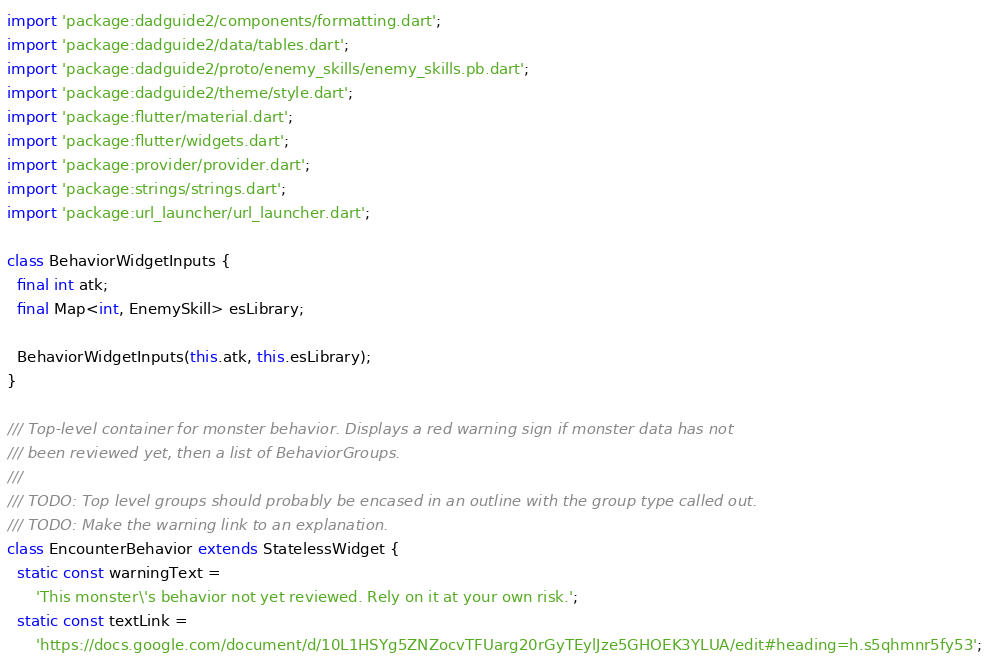Convert code to text. <code><loc_0><loc_0><loc_500><loc_500><_Dart_>import 'package:dadguide2/components/formatting.dart';
import 'package:dadguide2/data/tables.dart';
import 'package:dadguide2/proto/enemy_skills/enemy_skills.pb.dart';
import 'package:dadguide2/theme/style.dart';
import 'package:flutter/material.dart';
import 'package:flutter/widgets.dart';
import 'package:provider/provider.dart';
import 'package:strings/strings.dart';
import 'package:url_launcher/url_launcher.dart';

class BehaviorWidgetInputs {
  final int atk;
  final Map<int, EnemySkill> esLibrary;

  BehaviorWidgetInputs(this.atk, this.esLibrary);
}

/// Top-level container for monster behavior. Displays a red warning sign if monster data has not
/// been reviewed yet, then a list of BehaviorGroups.
///
/// TODO: Top level groups should probably be encased in an outline with the group type called out.
/// TODO: Make the warning link to an explanation.
class EncounterBehavior extends StatelessWidget {
  static const warningText =
      'This monster\'s behavior not yet reviewed. Rely on it at your own risk.';
  static const textLink =
      'https://docs.google.com/document/d/10L1HSYg5ZNZocvTFUarg20rGyTEylJze5GHOEK3YLUA/edit#heading=h.s5qhmnr5fy53';
</code> 